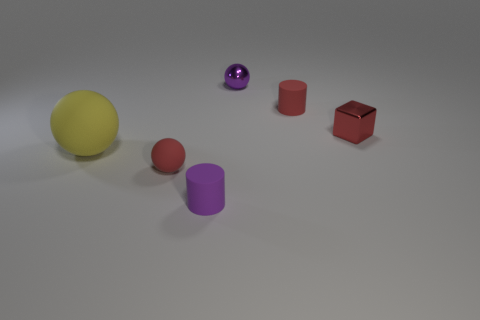Are there fewer big objects than small metal objects?
Your answer should be compact. Yes. What is the color of the small cylinder in front of the large thing?
Offer a very short reply. Purple. There is a thing that is both behind the yellow thing and to the left of the tiny red cylinder; what material is it?
Offer a very short reply. Metal. The purple thing that is the same material as the big sphere is what shape?
Keep it short and to the point. Cylinder. What number of tiny red objects are in front of the matte cylinder behind the red metal thing?
Provide a succinct answer. 2. How many red things are both in front of the big ball and behind the tiny red metal object?
Your response must be concise. 0. How many other objects are the same material as the small red cylinder?
Your response must be concise. 3. What color is the tiny cylinder that is behind the small cylinder left of the red rubber cylinder?
Your response must be concise. Red. Does the tiny rubber thing that is behind the small red ball have the same color as the small metallic ball?
Your answer should be very brief. No. Do the yellow rubber ball and the cube have the same size?
Your answer should be very brief. No. 